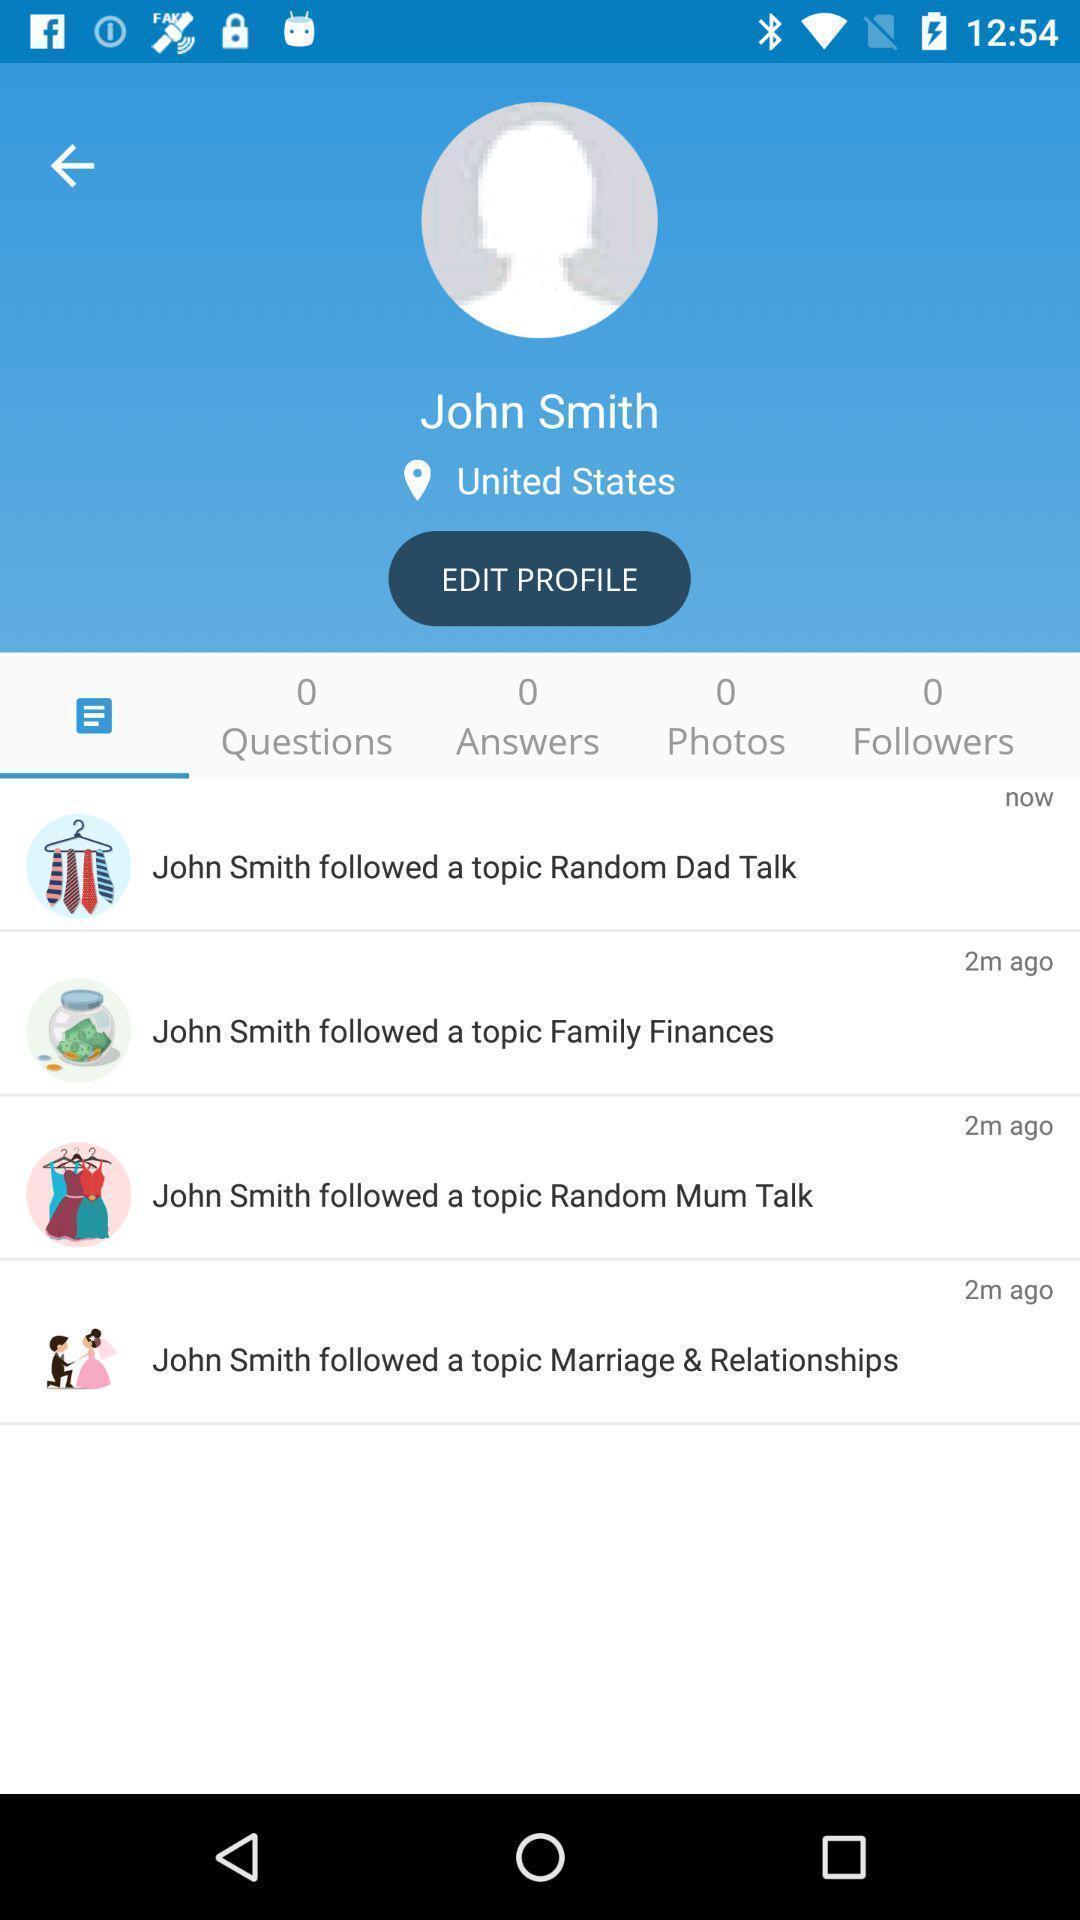What is the overall content of this screenshot? Page displaying the profile of the user. 